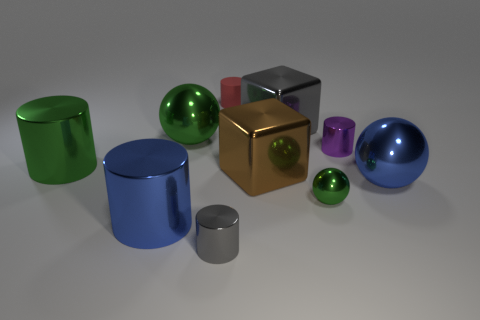Subtract all purple cylinders. How many cylinders are left? 4 Subtract all big green cylinders. How many cylinders are left? 4 Subtract 1 cylinders. How many cylinders are left? 4 Subtract all yellow cylinders. Subtract all blue blocks. How many cylinders are left? 5 Subtract all blocks. How many objects are left? 8 Add 7 small yellow rubber blocks. How many small yellow rubber blocks exist? 7 Subtract 1 blue cylinders. How many objects are left? 9 Subtract all green spheres. Subtract all small purple metallic cylinders. How many objects are left? 7 Add 9 brown metallic blocks. How many brown metallic blocks are left? 10 